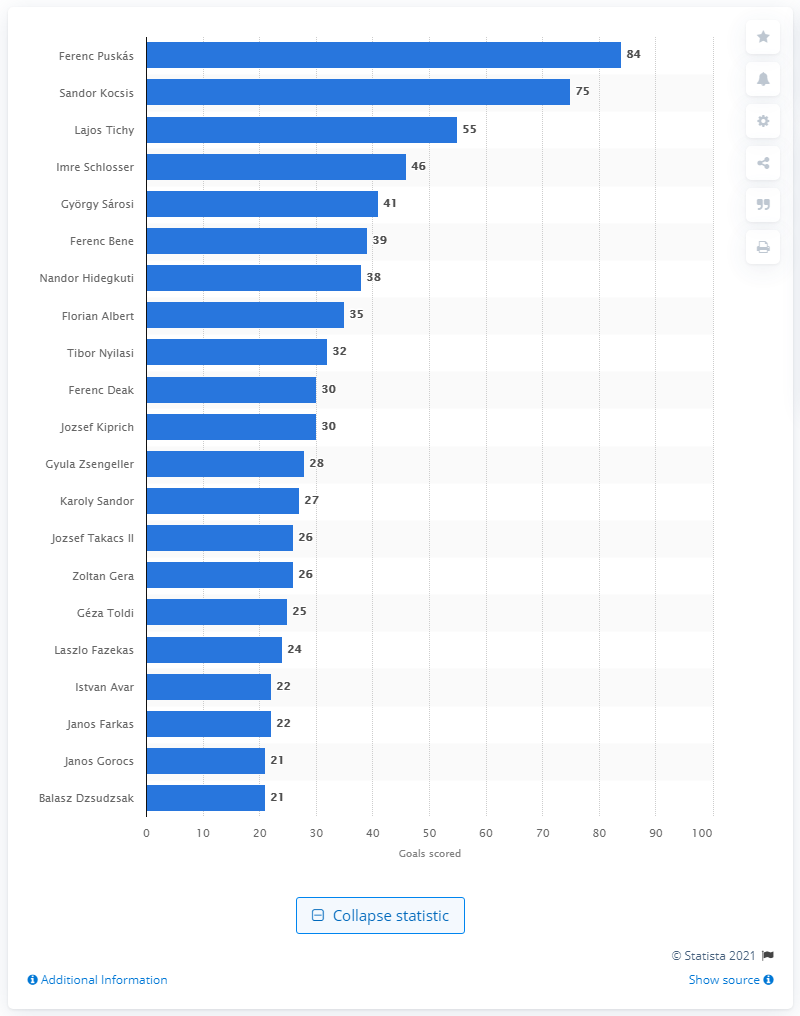List a handful of essential elements in this visual. Hungary's second leading goal scorer is Sandor Kocsis. 